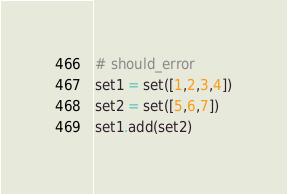<code> <loc_0><loc_0><loc_500><loc_500><_Python_># should_error
set1 = set([1,2,3,4])
set2 = set([5,6,7])
set1.add(set2)
</code> 